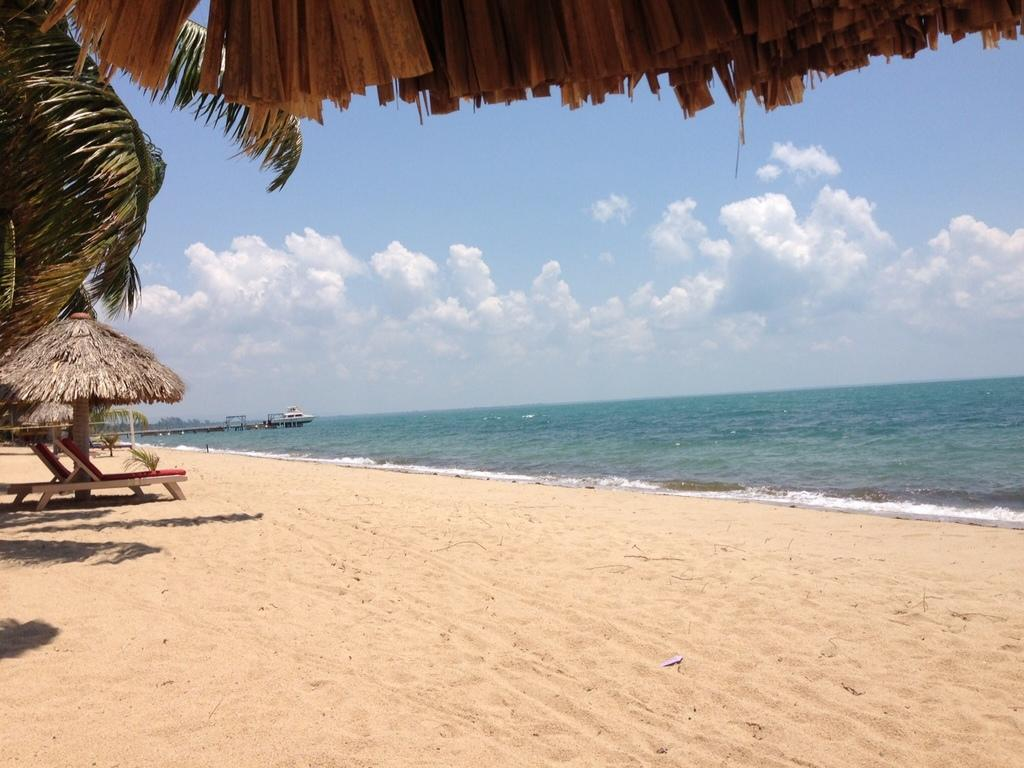What type of location is depicted in the image? The image shows a beach area. What is the condition of the sky in the background? The sky is cloudy in the background. Where are the tables located in the image? The tables are on the left side of the image. Is there a pest problem at the beach in the image? There is no information about a pest problem in the image, as it focuses on the beach area, cloudy sky, and tables. 